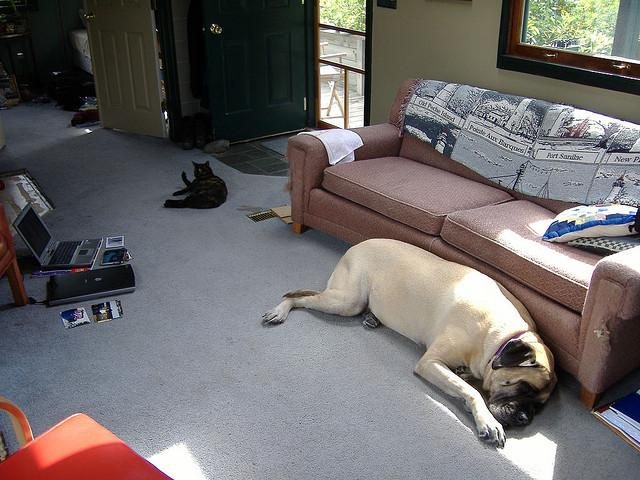Where is the person most likely working in the living room while the pets lounge? floor 